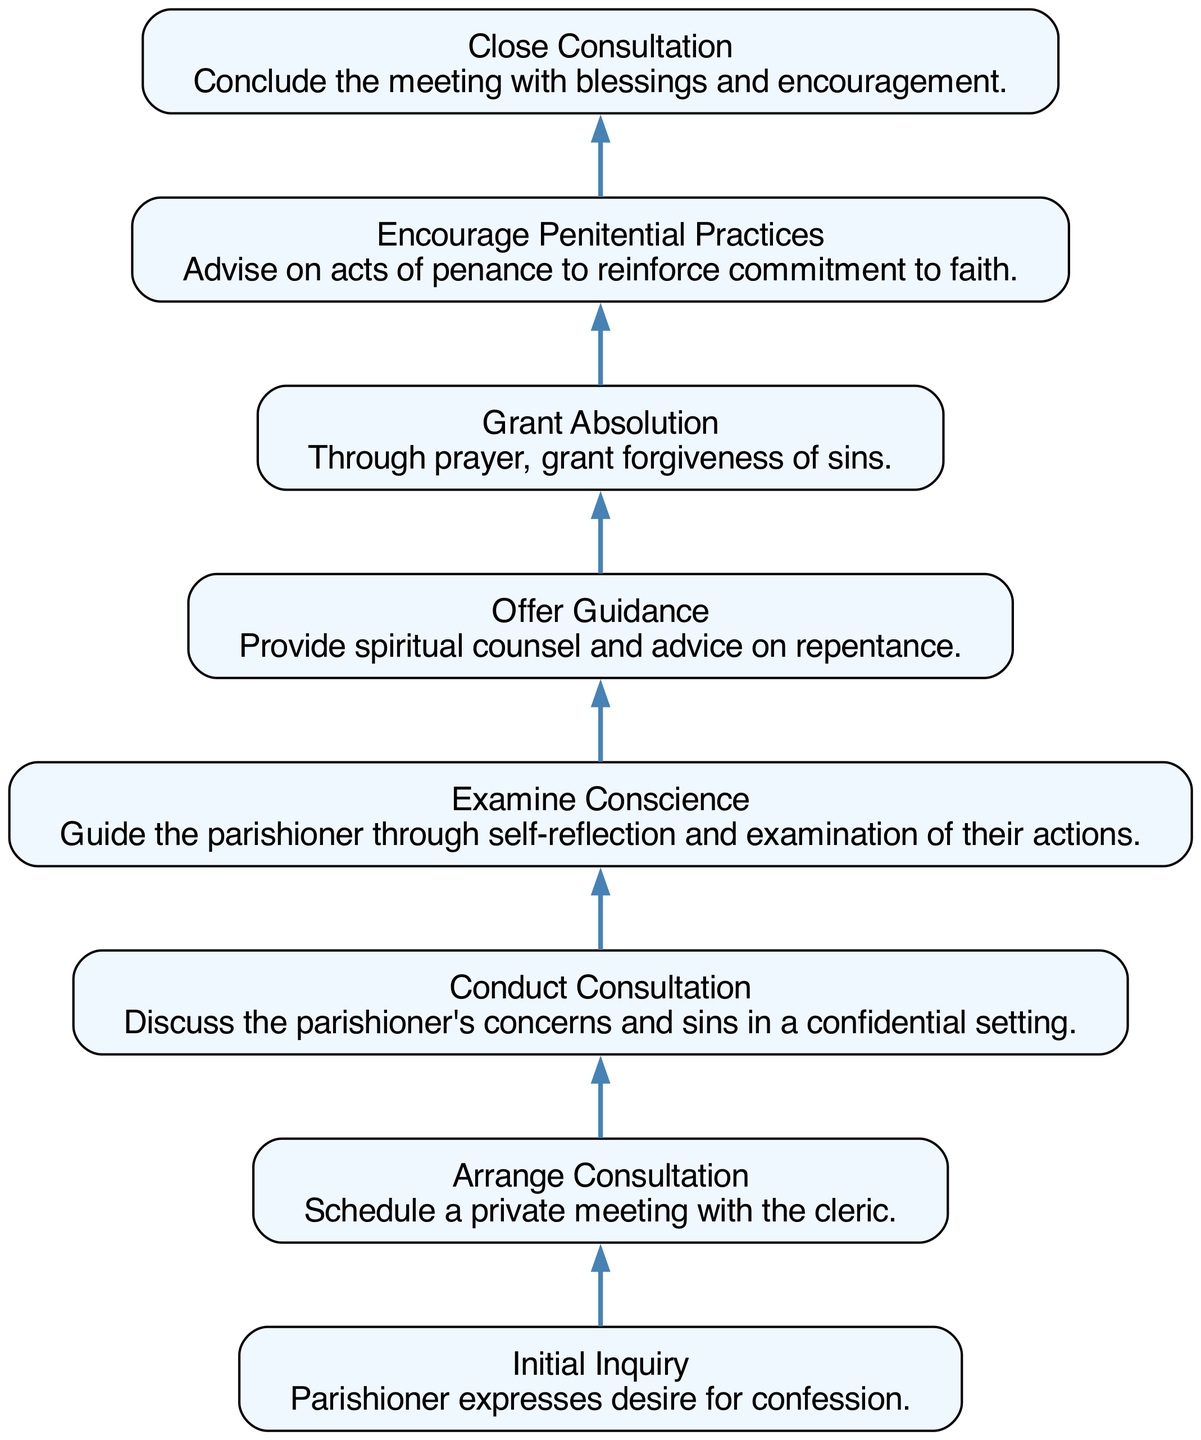What is the first step in the workflow? The first step in the workflow is labeled "Initial Inquiry" where the parishioner expresses a desire for confession. This is identified by the first node in the flow chart.
Answer: Initial Inquiry How many total steps are there in the workflow? By counting the nodes listed in the diagram, there are a total of 8 steps present, starting from "Initial Inquiry" to "Close Consultation."
Answer: 8 What step follows "Examine Conscience"? According to the flow diagram, the next step directly following "Examine Conscience" is "Offer Guidance," indicating the transition from reflection to counsel.
Answer: Offer Guidance Which step involves granting forgiveness? The step that involves granting forgiveness is labeled "Grant Absolution," which is a significant action performed after spiritual guidance is offered.
Answer: Grant Absolution What is the last step of the workflow? The last step in the workflow is "Close Consultation," which involves concluding the meeting with blessings and encouragement. This is the final node in the flowchart.
Answer: Close Consultation What two steps are encouraged after "Grant Absolution"? After "Grant Absolution," the workflow indicates two subsequent steps to be "Encourage Penitential Practices" and "Close Consultation," following the granting of forgiveness.
Answer: Encourage Penitential Practices, Close Consultation What is the primary action taken in the "Conduct Consultation" step? The primary action in the "Conduct Consultation" step consists of discussing the parishioner's concerns and sins in a confidential setting, as described in that node of the diagram.
Answer: Discuss concerns and sins Which step is focused on self-reflection? The step focused on self-reflection is "Examine Conscience," where the cleric guides the parishioner to reflect upon their actions before proceeding further in the confession process.
Answer: Examine Conscience 